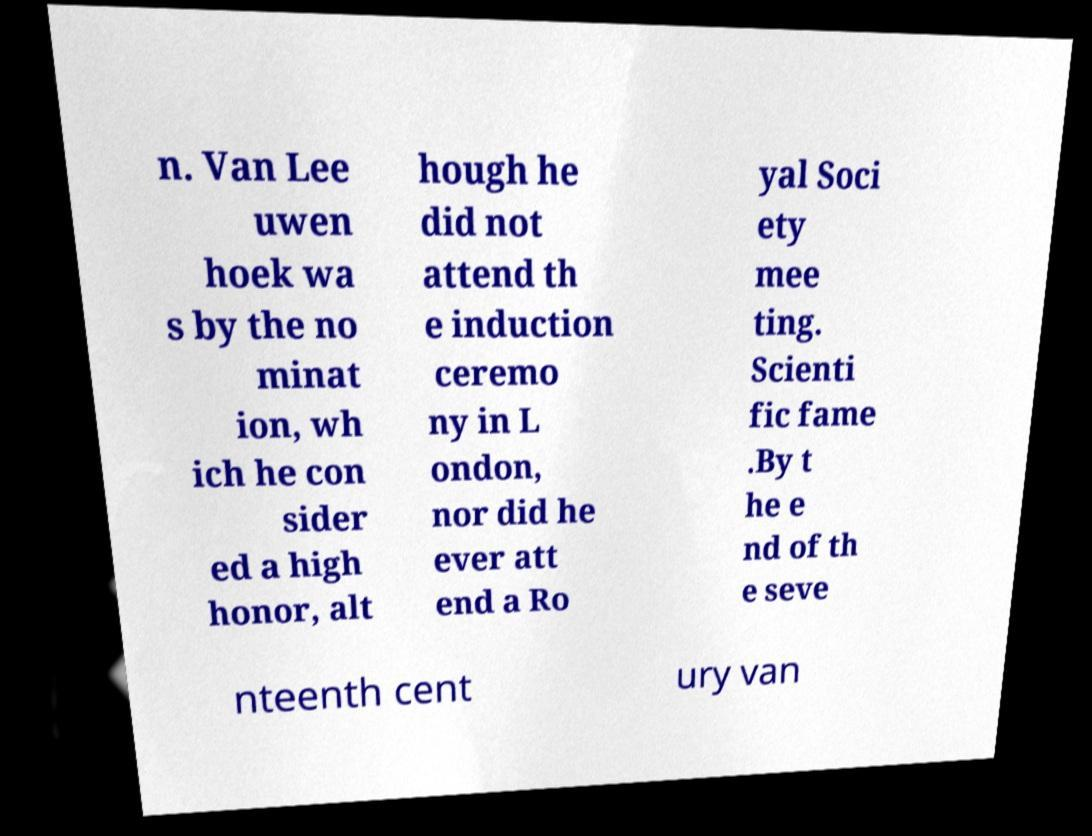Please read and relay the text visible in this image. What does it say? n. Van Lee uwen hoek wa s by the no minat ion, wh ich he con sider ed a high honor, alt hough he did not attend th e induction ceremo ny in L ondon, nor did he ever att end a Ro yal Soci ety mee ting. Scienti fic fame .By t he e nd of th e seve nteenth cent ury van 